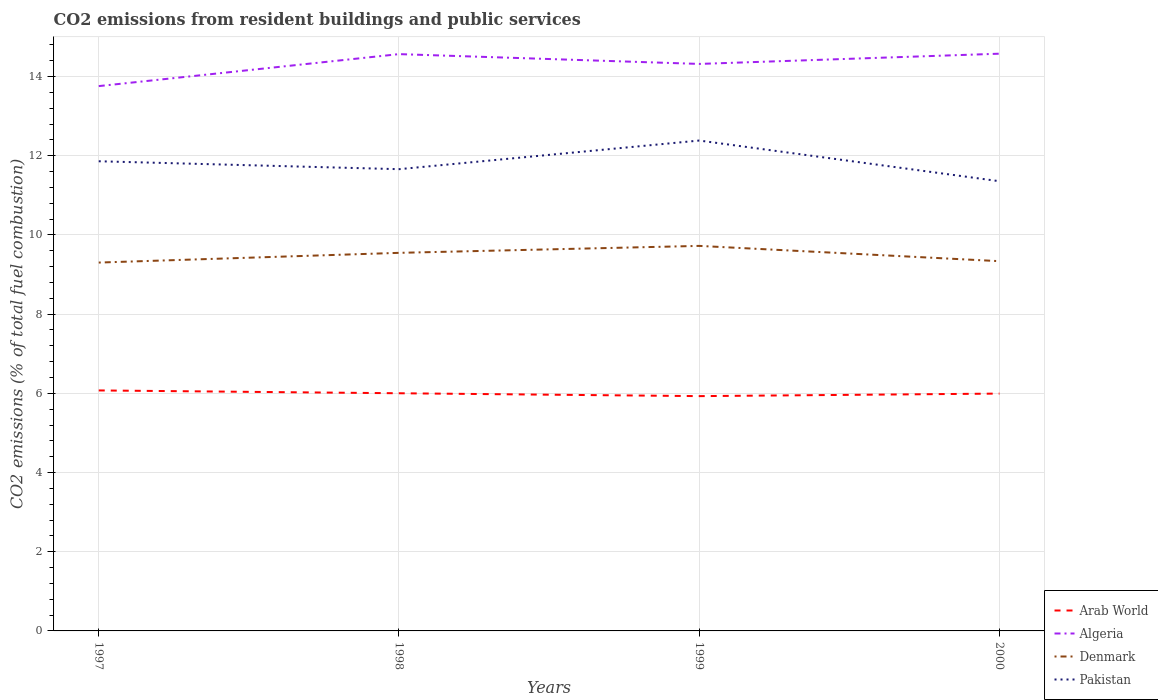How many different coloured lines are there?
Keep it short and to the point. 4. Is the number of lines equal to the number of legend labels?
Give a very brief answer. Yes. Across all years, what is the maximum total CO2 emitted in Pakistan?
Provide a short and direct response. 11.36. What is the total total CO2 emitted in Pakistan in the graph?
Give a very brief answer. 0.5. What is the difference between the highest and the second highest total CO2 emitted in Arab World?
Your answer should be very brief. 0.14. What is the difference between the highest and the lowest total CO2 emitted in Algeria?
Keep it short and to the point. 3. Is the total CO2 emitted in Denmark strictly greater than the total CO2 emitted in Pakistan over the years?
Your answer should be compact. Yes. How many lines are there?
Provide a short and direct response. 4. What is the difference between two consecutive major ticks on the Y-axis?
Make the answer very short. 2. How are the legend labels stacked?
Provide a short and direct response. Vertical. What is the title of the graph?
Ensure brevity in your answer.  CO2 emissions from resident buildings and public services. What is the label or title of the X-axis?
Keep it short and to the point. Years. What is the label or title of the Y-axis?
Keep it short and to the point. CO2 emissions (% of total fuel combustion). What is the CO2 emissions (% of total fuel combustion) of Arab World in 1997?
Give a very brief answer. 6.07. What is the CO2 emissions (% of total fuel combustion) in Algeria in 1997?
Offer a terse response. 13.76. What is the CO2 emissions (% of total fuel combustion) in Denmark in 1997?
Provide a short and direct response. 9.3. What is the CO2 emissions (% of total fuel combustion) in Pakistan in 1997?
Keep it short and to the point. 11.86. What is the CO2 emissions (% of total fuel combustion) of Arab World in 1998?
Provide a succinct answer. 6. What is the CO2 emissions (% of total fuel combustion) in Algeria in 1998?
Provide a succinct answer. 14.57. What is the CO2 emissions (% of total fuel combustion) of Denmark in 1998?
Keep it short and to the point. 9.55. What is the CO2 emissions (% of total fuel combustion) in Pakistan in 1998?
Provide a succinct answer. 11.66. What is the CO2 emissions (% of total fuel combustion) of Arab World in 1999?
Offer a very short reply. 5.93. What is the CO2 emissions (% of total fuel combustion) in Algeria in 1999?
Keep it short and to the point. 14.32. What is the CO2 emissions (% of total fuel combustion) in Denmark in 1999?
Give a very brief answer. 9.72. What is the CO2 emissions (% of total fuel combustion) of Pakistan in 1999?
Ensure brevity in your answer.  12.38. What is the CO2 emissions (% of total fuel combustion) of Arab World in 2000?
Your response must be concise. 5.99. What is the CO2 emissions (% of total fuel combustion) of Algeria in 2000?
Your response must be concise. 14.58. What is the CO2 emissions (% of total fuel combustion) in Denmark in 2000?
Provide a succinct answer. 9.34. What is the CO2 emissions (% of total fuel combustion) of Pakistan in 2000?
Provide a succinct answer. 11.36. Across all years, what is the maximum CO2 emissions (% of total fuel combustion) in Arab World?
Keep it short and to the point. 6.07. Across all years, what is the maximum CO2 emissions (% of total fuel combustion) in Algeria?
Offer a very short reply. 14.58. Across all years, what is the maximum CO2 emissions (% of total fuel combustion) in Denmark?
Ensure brevity in your answer.  9.72. Across all years, what is the maximum CO2 emissions (% of total fuel combustion) of Pakistan?
Provide a succinct answer. 12.38. Across all years, what is the minimum CO2 emissions (% of total fuel combustion) of Arab World?
Offer a terse response. 5.93. Across all years, what is the minimum CO2 emissions (% of total fuel combustion) in Algeria?
Provide a succinct answer. 13.76. Across all years, what is the minimum CO2 emissions (% of total fuel combustion) in Denmark?
Ensure brevity in your answer.  9.3. Across all years, what is the minimum CO2 emissions (% of total fuel combustion) in Pakistan?
Make the answer very short. 11.36. What is the total CO2 emissions (% of total fuel combustion) of Algeria in the graph?
Make the answer very short. 57.22. What is the total CO2 emissions (% of total fuel combustion) in Denmark in the graph?
Make the answer very short. 37.91. What is the total CO2 emissions (% of total fuel combustion) of Pakistan in the graph?
Offer a terse response. 47.27. What is the difference between the CO2 emissions (% of total fuel combustion) of Arab World in 1997 and that in 1998?
Your answer should be compact. 0.07. What is the difference between the CO2 emissions (% of total fuel combustion) of Algeria in 1997 and that in 1998?
Ensure brevity in your answer.  -0.81. What is the difference between the CO2 emissions (% of total fuel combustion) in Denmark in 1997 and that in 1998?
Make the answer very short. -0.25. What is the difference between the CO2 emissions (% of total fuel combustion) in Arab World in 1997 and that in 1999?
Your answer should be very brief. 0.14. What is the difference between the CO2 emissions (% of total fuel combustion) in Algeria in 1997 and that in 1999?
Your answer should be compact. -0.56. What is the difference between the CO2 emissions (% of total fuel combustion) in Denmark in 1997 and that in 1999?
Provide a short and direct response. -0.42. What is the difference between the CO2 emissions (% of total fuel combustion) of Pakistan in 1997 and that in 1999?
Offer a terse response. -0.52. What is the difference between the CO2 emissions (% of total fuel combustion) in Arab World in 1997 and that in 2000?
Provide a succinct answer. 0.08. What is the difference between the CO2 emissions (% of total fuel combustion) of Algeria in 1997 and that in 2000?
Give a very brief answer. -0.82. What is the difference between the CO2 emissions (% of total fuel combustion) of Denmark in 1997 and that in 2000?
Make the answer very short. -0.04. What is the difference between the CO2 emissions (% of total fuel combustion) in Pakistan in 1997 and that in 2000?
Keep it short and to the point. 0.5. What is the difference between the CO2 emissions (% of total fuel combustion) in Arab World in 1998 and that in 1999?
Provide a succinct answer. 0.07. What is the difference between the CO2 emissions (% of total fuel combustion) in Algeria in 1998 and that in 1999?
Offer a terse response. 0.25. What is the difference between the CO2 emissions (% of total fuel combustion) in Denmark in 1998 and that in 1999?
Keep it short and to the point. -0.18. What is the difference between the CO2 emissions (% of total fuel combustion) of Pakistan in 1998 and that in 1999?
Give a very brief answer. -0.72. What is the difference between the CO2 emissions (% of total fuel combustion) in Arab World in 1998 and that in 2000?
Your answer should be compact. 0.01. What is the difference between the CO2 emissions (% of total fuel combustion) in Algeria in 1998 and that in 2000?
Offer a very short reply. -0.01. What is the difference between the CO2 emissions (% of total fuel combustion) in Denmark in 1998 and that in 2000?
Keep it short and to the point. 0.21. What is the difference between the CO2 emissions (% of total fuel combustion) in Pakistan in 1998 and that in 2000?
Give a very brief answer. 0.3. What is the difference between the CO2 emissions (% of total fuel combustion) in Arab World in 1999 and that in 2000?
Ensure brevity in your answer.  -0.06. What is the difference between the CO2 emissions (% of total fuel combustion) in Algeria in 1999 and that in 2000?
Ensure brevity in your answer.  -0.26. What is the difference between the CO2 emissions (% of total fuel combustion) in Denmark in 1999 and that in 2000?
Keep it short and to the point. 0.39. What is the difference between the CO2 emissions (% of total fuel combustion) in Pakistan in 1999 and that in 2000?
Provide a succinct answer. 1.03. What is the difference between the CO2 emissions (% of total fuel combustion) in Arab World in 1997 and the CO2 emissions (% of total fuel combustion) in Algeria in 1998?
Offer a very short reply. -8.49. What is the difference between the CO2 emissions (% of total fuel combustion) of Arab World in 1997 and the CO2 emissions (% of total fuel combustion) of Denmark in 1998?
Give a very brief answer. -3.47. What is the difference between the CO2 emissions (% of total fuel combustion) in Arab World in 1997 and the CO2 emissions (% of total fuel combustion) in Pakistan in 1998?
Your answer should be very brief. -5.59. What is the difference between the CO2 emissions (% of total fuel combustion) in Algeria in 1997 and the CO2 emissions (% of total fuel combustion) in Denmark in 1998?
Give a very brief answer. 4.21. What is the difference between the CO2 emissions (% of total fuel combustion) in Algeria in 1997 and the CO2 emissions (% of total fuel combustion) in Pakistan in 1998?
Make the answer very short. 2.1. What is the difference between the CO2 emissions (% of total fuel combustion) of Denmark in 1997 and the CO2 emissions (% of total fuel combustion) of Pakistan in 1998?
Your response must be concise. -2.36. What is the difference between the CO2 emissions (% of total fuel combustion) of Arab World in 1997 and the CO2 emissions (% of total fuel combustion) of Algeria in 1999?
Your answer should be compact. -8.25. What is the difference between the CO2 emissions (% of total fuel combustion) of Arab World in 1997 and the CO2 emissions (% of total fuel combustion) of Denmark in 1999?
Make the answer very short. -3.65. What is the difference between the CO2 emissions (% of total fuel combustion) of Arab World in 1997 and the CO2 emissions (% of total fuel combustion) of Pakistan in 1999?
Your answer should be very brief. -6.31. What is the difference between the CO2 emissions (% of total fuel combustion) in Algeria in 1997 and the CO2 emissions (% of total fuel combustion) in Denmark in 1999?
Provide a succinct answer. 4.04. What is the difference between the CO2 emissions (% of total fuel combustion) of Algeria in 1997 and the CO2 emissions (% of total fuel combustion) of Pakistan in 1999?
Ensure brevity in your answer.  1.37. What is the difference between the CO2 emissions (% of total fuel combustion) in Denmark in 1997 and the CO2 emissions (% of total fuel combustion) in Pakistan in 1999?
Your answer should be compact. -3.08. What is the difference between the CO2 emissions (% of total fuel combustion) in Arab World in 1997 and the CO2 emissions (% of total fuel combustion) in Algeria in 2000?
Ensure brevity in your answer.  -8.5. What is the difference between the CO2 emissions (% of total fuel combustion) in Arab World in 1997 and the CO2 emissions (% of total fuel combustion) in Denmark in 2000?
Provide a succinct answer. -3.26. What is the difference between the CO2 emissions (% of total fuel combustion) in Arab World in 1997 and the CO2 emissions (% of total fuel combustion) in Pakistan in 2000?
Ensure brevity in your answer.  -5.28. What is the difference between the CO2 emissions (% of total fuel combustion) in Algeria in 1997 and the CO2 emissions (% of total fuel combustion) in Denmark in 2000?
Your response must be concise. 4.42. What is the difference between the CO2 emissions (% of total fuel combustion) in Algeria in 1997 and the CO2 emissions (% of total fuel combustion) in Pakistan in 2000?
Your answer should be very brief. 2.4. What is the difference between the CO2 emissions (% of total fuel combustion) of Denmark in 1997 and the CO2 emissions (% of total fuel combustion) of Pakistan in 2000?
Your response must be concise. -2.05. What is the difference between the CO2 emissions (% of total fuel combustion) of Arab World in 1998 and the CO2 emissions (% of total fuel combustion) of Algeria in 1999?
Your answer should be very brief. -8.32. What is the difference between the CO2 emissions (% of total fuel combustion) in Arab World in 1998 and the CO2 emissions (% of total fuel combustion) in Denmark in 1999?
Your answer should be very brief. -3.72. What is the difference between the CO2 emissions (% of total fuel combustion) in Arab World in 1998 and the CO2 emissions (% of total fuel combustion) in Pakistan in 1999?
Provide a short and direct response. -6.38. What is the difference between the CO2 emissions (% of total fuel combustion) in Algeria in 1998 and the CO2 emissions (% of total fuel combustion) in Denmark in 1999?
Your response must be concise. 4.84. What is the difference between the CO2 emissions (% of total fuel combustion) in Algeria in 1998 and the CO2 emissions (% of total fuel combustion) in Pakistan in 1999?
Make the answer very short. 2.18. What is the difference between the CO2 emissions (% of total fuel combustion) in Denmark in 1998 and the CO2 emissions (% of total fuel combustion) in Pakistan in 1999?
Your response must be concise. -2.84. What is the difference between the CO2 emissions (% of total fuel combustion) of Arab World in 1998 and the CO2 emissions (% of total fuel combustion) of Algeria in 2000?
Keep it short and to the point. -8.58. What is the difference between the CO2 emissions (% of total fuel combustion) in Arab World in 1998 and the CO2 emissions (% of total fuel combustion) in Denmark in 2000?
Offer a very short reply. -3.34. What is the difference between the CO2 emissions (% of total fuel combustion) of Arab World in 1998 and the CO2 emissions (% of total fuel combustion) of Pakistan in 2000?
Ensure brevity in your answer.  -5.36. What is the difference between the CO2 emissions (% of total fuel combustion) of Algeria in 1998 and the CO2 emissions (% of total fuel combustion) of Denmark in 2000?
Your answer should be very brief. 5.23. What is the difference between the CO2 emissions (% of total fuel combustion) in Algeria in 1998 and the CO2 emissions (% of total fuel combustion) in Pakistan in 2000?
Provide a succinct answer. 3.21. What is the difference between the CO2 emissions (% of total fuel combustion) of Denmark in 1998 and the CO2 emissions (% of total fuel combustion) of Pakistan in 2000?
Your response must be concise. -1.81. What is the difference between the CO2 emissions (% of total fuel combustion) in Arab World in 1999 and the CO2 emissions (% of total fuel combustion) in Algeria in 2000?
Your answer should be very brief. -8.65. What is the difference between the CO2 emissions (% of total fuel combustion) in Arab World in 1999 and the CO2 emissions (% of total fuel combustion) in Denmark in 2000?
Provide a succinct answer. -3.41. What is the difference between the CO2 emissions (% of total fuel combustion) in Arab World in 1999 and the CO2 emissions (% of total fuel combustion) in Pakistan in 2000?
Your response must be concise. -5.43. What is the difference between the CO2 emissions (% of total fuel combustion) in Algeria in 1999 and the CO2 emissions (% of total fuel combustion) in Denmark in 2000?
Provide a short and direct response. 4.98. What is the difference between the CO2 emissions (% of total fuel combustion) in Algeria in 1999 and the CO2 emissions (% of total fuel combustion) in Pakistan in 2000?
Your response must be concise. 2.96. What is the difference between the CO2 emissions (% of total fuel combustion) in Denmark in 1999 and the CO2 emissions (% of total fuel combustion) in Pakistan in 2000?
Your response must be concise. -1.63. What is the average CO2 emissions (% of total fuel combustion) in Algeria per year?
Offer a very short reply. 14.31. What is the average CO2 emissions (% of total fuel combustion) in Denmark per year?
Keep it short and to the point. 9.48. What is the average CO2 emissions (% of total fuel combustion) of Pakistan per year?
Your answer should be very brief. 11.82. In the year 1997, what is the difference between the CO2 emissions (% of total fuel combustion) in Arab World and CO2 emissions (% of total fuel combustion) in Algeria?
Your answer should be compact. -7.69. In the year 1997, what is the difference between the CO2 emissions (% of total fuel combustion) in Arab World and CO2 emissions (% of total fuel combustion) in Denmark?
Provide a short and direct response. -3.23. In the year 1997, what is the difference between the CO2 emissions (% of total fuel combustion) in Arab World and CO2 emissions (% of total fuel combustion) in Pakistan?
Give a very brief answer. -5.79. In the year 1997, what is the difference between the CO2 emissions (% of total fuel combustion) in Algeria and CO2 emissions (% of total fuel combustion) in Denmark?
Offer a terse response. 4.46. In the year 1997, what is the difference between the CO2 emissions (% of total fuel combustion) in Algeria and CO2 emissions (% of total fuel combustion) in Pakistan?
Make the answer very short. 1.9. In the year 1997, what is the difference between the CO2 emissions (% of total fuel combustion) in Denmark and CO2 emissions (% of total fuel combustion) in Pakistan?
Make the answer very short. -2.56. In the year 1998, what is the difference between the CO2 emissions (% of total fuel combustion) of Arab World and CO2 emissions (% of total fuel combustion) of Algeria?
Make the answer very short. -8.56. In the year 1998, what is the difference between the CO2 emissions (% of total fuel combustion) of Arab World and CO2 emissions (% of total fuel combustion) of Denmark?
Provide a succinct answer. -3.55. In the year 1998, what is the difference between the CO2 emissions (% of total fuel combustion) of Arab World and CO2 emissions (% of total fuel combustion) of Pakistan?
Keep it short and to the point. -5.66. In the year 1998, what is the difference between the CO2 emissions (% of total fuel combustion) in Algeria and CO2 emissions (% of total fuel combustion) in Denmark?
Make the answer very short. 5.02. In the year 1998, what is the difference between the CO2 emissions (% of total fuel combustion) of Algeria and CO2 emissions (% of total fuel combustion) of Pakistan?
Make the answer very short. 2.91. In the year 1998, what is the difference between the CO2 emissions (% of total fuel combustion) of Denmark and CO2 emissions (% of total fuel combustion) of Pakistan?
Give a very brief answer. -2.11. In the year 1999, what is the difference between the CO2 emissions (% of total fuel combustion) in Arab World and CO2 emissions (% of total fuel combustion) in Algeria?
Your answer should be very brief. -8.39. In the year 1999, what is the difference between the CO2 emissions (% of total fuel combustion) in Arab World and CO2 emissions (% of total fuel combustion) in Denmark?
Keep it short and to the point. -3.79. In the year 1999, what is the difference between the CO2 emissions (% of total fuel combustion) of Arab World and CO2 emissions (% of total fuel combustion) of Pakistan?
Give a very brief answer. -6.45. In the year 1999, what is the difference between the CO2 emissions (% of total fuel combustion) in Algeria and CO2 emissions (% of total fuel combustion) in Denmark?
Keep it short and to the point. 4.6. In the year 1999, what is the difference between the CO2 emissions (% of total fuel combustion) in Algeria and CO2 emissions (% of total fuel combustion) in Pakistan?
Make the answer very short. 1.94. In the year 1999, what is the difference between the CO2 emissions (% of total fuel combustion) in Denmark and CO2 emissions (% of total fuel combustion) in Pakistan?
Make the answer very short. -2.66. In the year 2000, what is the difference between the CO2 emissions (% of total fuel combustion) of Arab World and CO2 emissions (% of total fuel combustion) of Algeria?
Ensure brevity in your answer.  -8.58. In the year 2000, what is the difference between the CO2 emissions (% of total fuel combustion) in Arab World and CO2 emissions (% of total fuel combustion) in Denmark?
Ensure brevity in your answer.  -3.34. In the year 2000, what is the difference between the CO2 emissions (% of total fuel combustion) of Arab World and CO2 emissions (% of total fuel combustion) of Pakistan?
Your answer should be very brief. -5.36. In the year 2000, what is the difference between the CO2 emissions (% of total fuel combustion) in Algeria and CO2 emissions (% of total fuel combustion) in Denmark?
Keep it short and to the point. 5.24. In the year 2000, what is the difference between the CO2 emissions (% of total fuel combustion) in Algeria and CO2 emissions (% of total fuel combustion) in Pakistan?
Your answer should be compact. 3.22. In the year 2000, what is the difference between the CO2 emissions (% of total fuel combustion) in Denmark and CO2 emissions (% of total fuel combustion) in Pakistan?
Keep it short and to the point. -2.02. What is the ratio of the CO2 emissions (% of total fuel combustion) in Arab World in 1997 to that in 1998?
Ensure brevity in your answer.  1.01. What is the ratio of the CO2 emissions (% of total fuel combustion) of Algeria in 1997 to that in 1998?
Keep it short and to the point. 0.94. What is the ratio of the CO2 emissions (% of total fuel combustion) of Denmark in 1997 to that in 1998?
Give a very brief answer. 0.97. What is the ratio of the CO2 emissions (% of total fuel combustion) of Pakistan in 1997 to that in 1998?
Your answer should be compact. 1.02. What is the ratio of the CO2 emissions (% of total fuel combustion) in Arab World in 1997 to that in 1999?
Make the answer very short. 1.02. What is the ratio of the CO2 emissions (% of total fuel combustion) of Algeria in 1997 to that in 1999?
Provide a short and direct response. 0.96. What is the ratio of the CO2 emissions (% of total fuel combustion) of Denmark in 1997 to that in 1999?
Keep it short and to the point. 0.96. What is the ratio of the CO2 emissions (% of total fuel combustion) of Pakistan in 1997 to that in 1999?
Your answer should be compact. 0.96. What is the ratio of the CO2 emissions (% of total fuel combustion) in Arab World in 1997 to that in 2000?
Your answer should be very brief. 1.01. What is the ratio of the CO2 emissions (% of total fuel combustion) of Algeria in 1997 to that in 2000?
Ensure brevity in your answer.  0.94. What is the ratio of the CO2 emissions (% of total fuel combustion) of Pakistan in 1997 to that in 2000?
Your response must be concise. 1.04. What is the ratio of the CO2 emissions (% of total fuel combustion) of Arab World in 1998 to that in 1999?
Your response must be concise. 1.01. What is the ratio of the CO2 emissions (% of total fuel combustion) in Algeria in 1998 to that in 1999?
Offer a terse response. 1.02. What is the ratio of the CO2 emissions (% of total fuel combustion) of Pakistan in 1998 to that in 1999?
Your answer should be compact. 0.94. What is the ratio of the CO2 emissions (% of total fuel combustion) of Arab World in 1998 to that in 2000?
Offer a terse response. 1. What is the ratio of the CO2 emissions (% of total fuel combustion) of Denmark in 1998 to that in 2000?
Offer a terse response. 1.02. What is the ratio of the CO2 emissions (% of total fuel combustion) of Pakistan in 1998 to that in 2000?
Provide a short and direct response. 1.03. What is the ratio of the CO2 emissions (% of total fuel combustion) of Arab World in 1999 to that in 2000?
Offer a terse response. 0.99. What is the ratio of the CO2 emissions (% of total fuel combustion) of Algeria in 1999 to that in 2000?
Your answer should be very brief. 0.98. What is the ratio of the CO2 emissions (% of total fuel combustion) of Denmark in 1999 to that in 2000?
Ensure brevity in your answer.  1.04. What is the ratio of the CO2 emissions (% of total fuel combustion) of Pakistan in 1999 to that in 2000?
Provide a succinct answer. 1.09. What is the difference between the highest and the second highest CO2 emissions (% of total fuel combustion) in Arab World?
Your answer should be compact. 0.07. What is the difference between the highest and the second highest CO2 emissions (% of total fuel combustion) of Algeria?
Keep it short and to the point. 0.01. What is the difference between the highest and the second highest CO2 emissions (% of total fuel combustion) in Denmark?
Your response must be concise. 0.18. What is the difference between the highest and the second highest CO2 emissions (% of total fuel combustion) in Pakistan?
Your answer should be compact. 0.52. What is the difference between the highest and the lowest CO2 emissions (% of total fuel combustion) of Arab World?
Make the answer very short. 0.14. What is the difference between the highest and the lowest CO2 emissions (% of total fuel combustion) of Algeria?
Offer a terse response. 0.82. What is the difference between the highest and the lowest CO2 emissions (% of total fuel combustion) of Denmark?
Your answer should be very brief. 0.42. What is the difference between the highest and the lowest CO2 emissions (% of total fuel combustion) of Pakistan?
Provide a succinct answer. 1.03. 